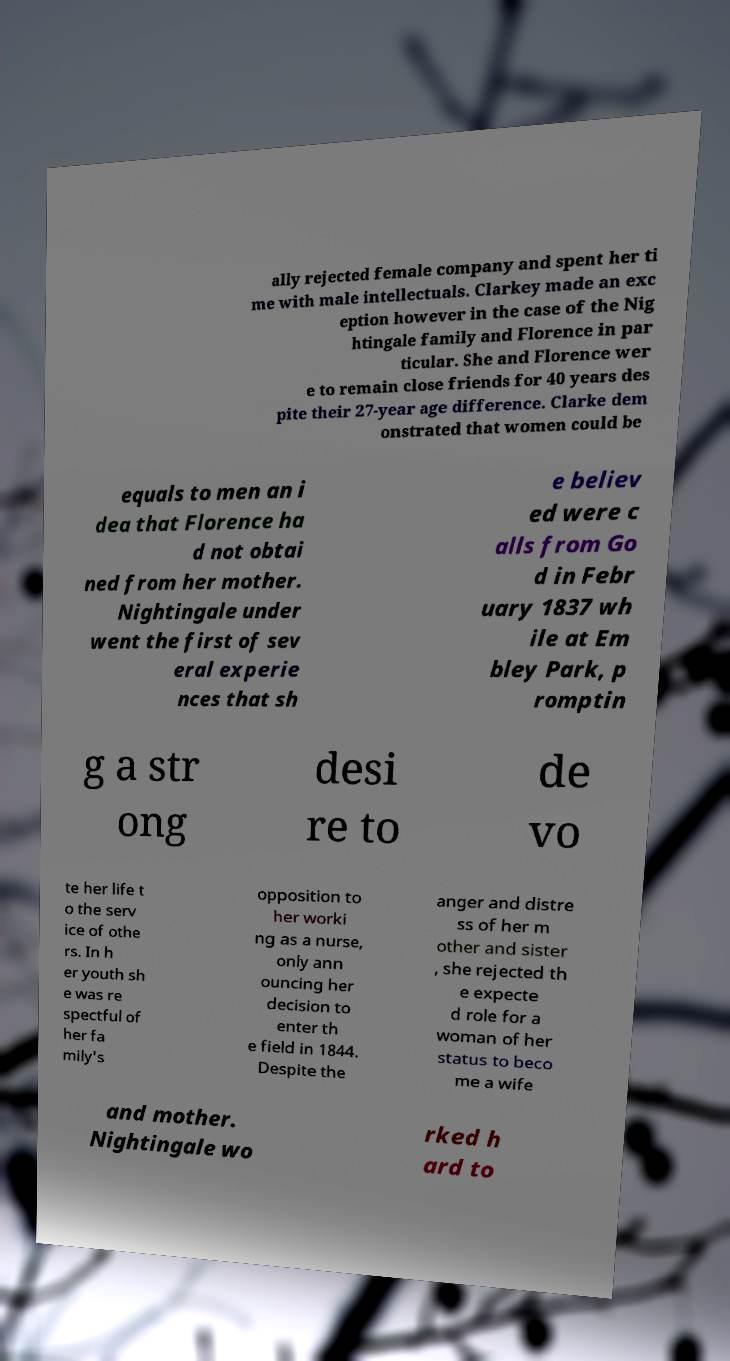Can you read and provide the text displayed in the image?This photo seems to have some interesting text. Can you extract and type it out for me? ally rejected female company and spent her ti me with male intellectuals. Clarkey made an exc eption however in the case of the Nig htingale family and Florence in par ticular. She and Florence wer e to remain close friends for 40 years des pite their 27-year age difference. Clarke dem onstrated that women could be equals to men an i dea that Florence ha d not obtai ned from her mother. Nightingale under went the first of sev eral experie nces that sh e believ ed were c alls from Go d in Febr uary 1837 wh ile at Em bley Park, p romptin g a str ong desi re to de vo te her life t o the serv ice of othe rs. In h er youth sh e was re spectful of her fa mily's opposition to her worki ng as a nurse, only ann ouncing her decision to enter th e field in 1844. Despite the anger and distre ss of her m other and sister , she rejected th e expecte d role for a woman of her status to beco me a wife and mother. Nightingale wo rked h ard to 